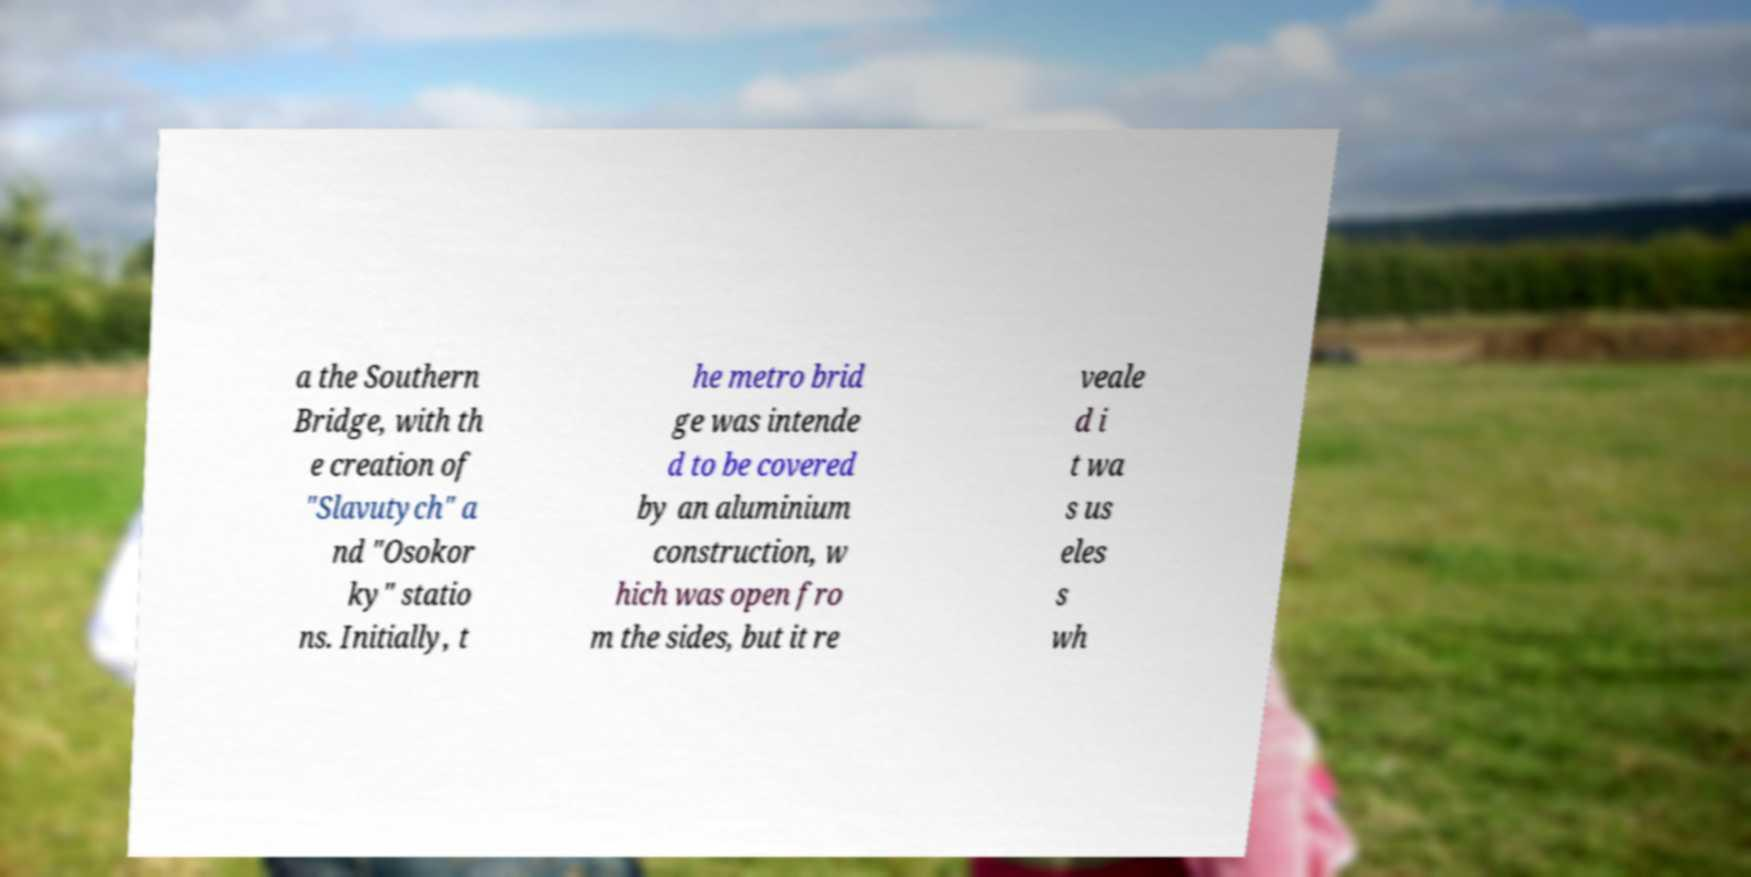Could you assist in decoding the text presented in this image and type it out clearly? a the Southern Bridge, with th e creation of "Slavutych" a nd "Osokor ky" statio ns. Initially, t he metro brid ge was intende d to be covered by an aluminium construction, w hich was open fro m the sides, but it re veale d i t wa s us eles s wh 